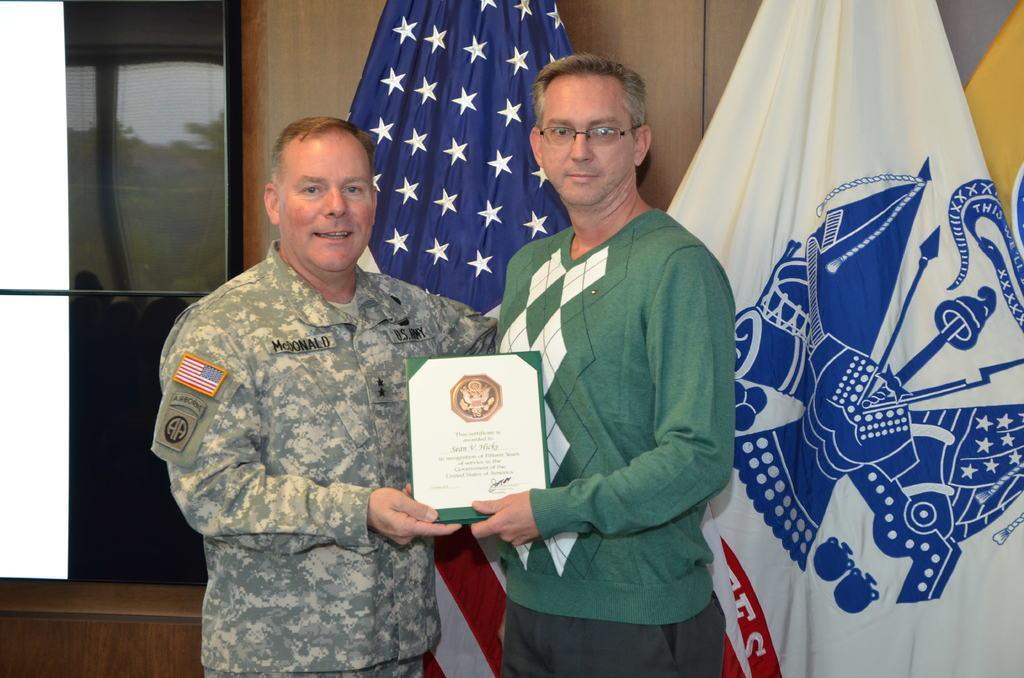In one or two sentences, can you explain what this image depicts? There are two persons holding a frame with one hand and standing on a floor. In the background, there are two flags near a wall. 